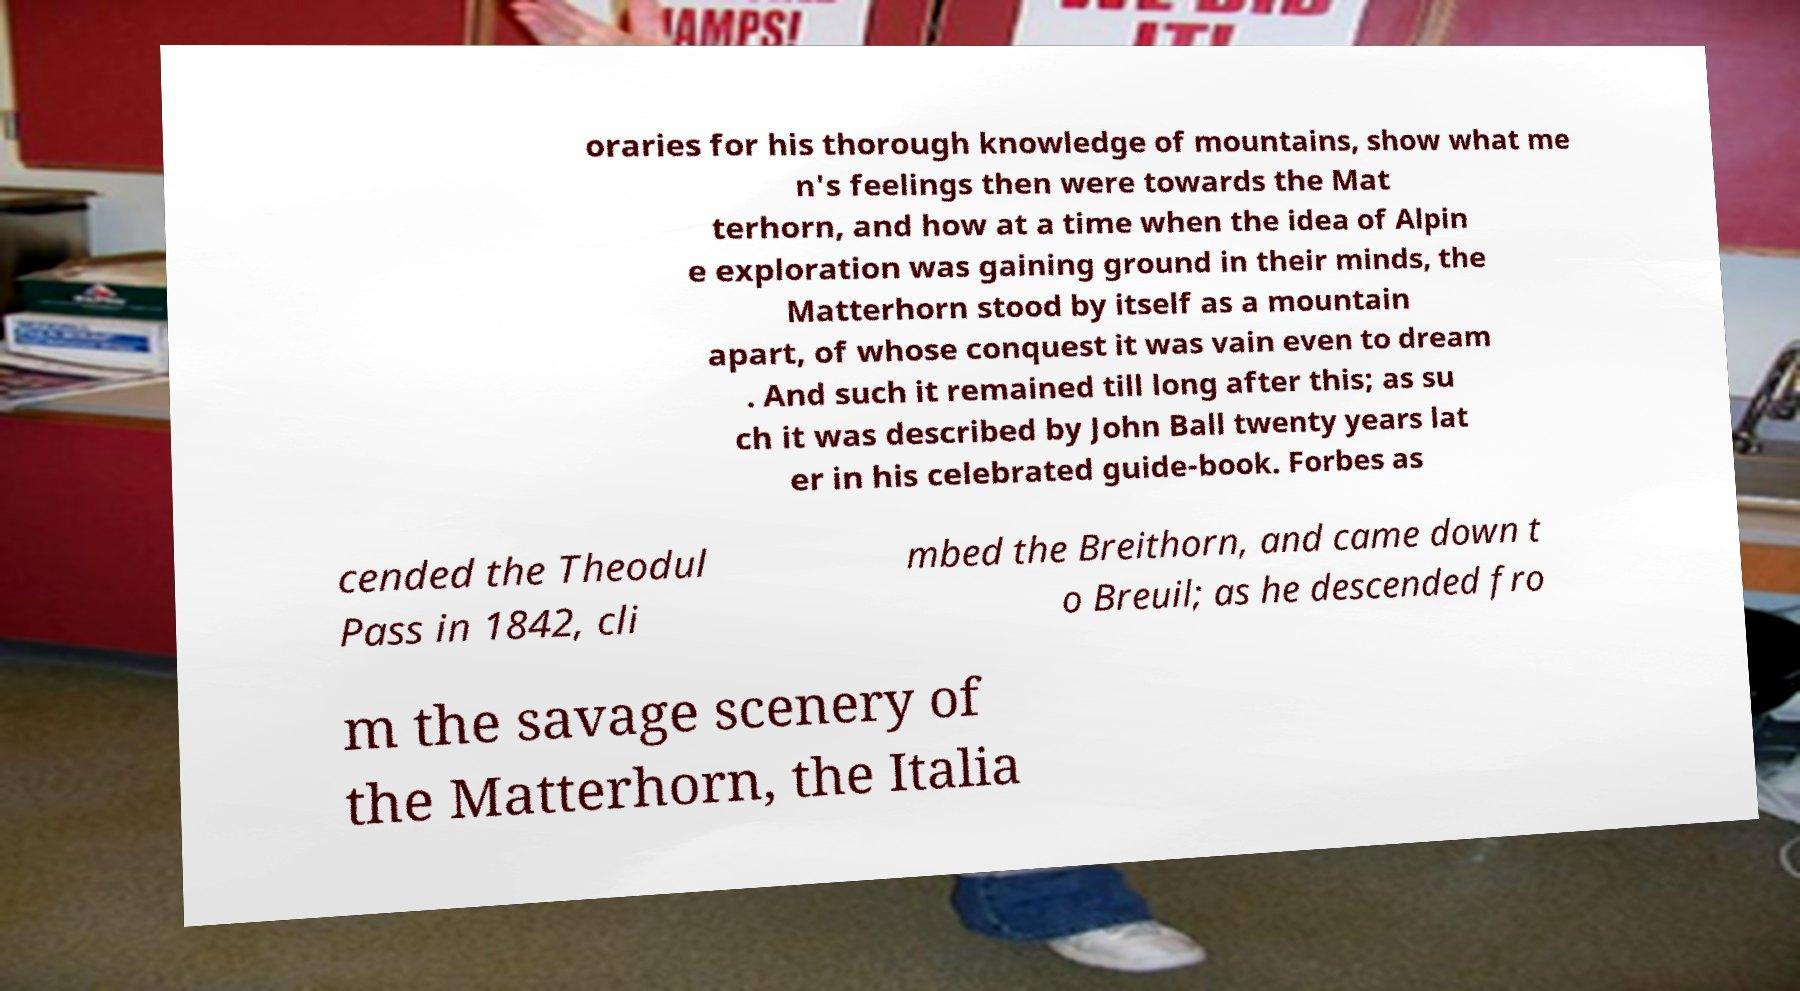Could you extract and type out the text from this image? oraries for his thorough knowledge of mountains, show what me n's feelings then were towards the Mat terhorn, and how at a time when the idea of Alpin e exploration was gaining ground in their minds, the Matterhorn stood by itself as a mountain apart, of whose conquest it was vain even to dream . And such it remained till long after this; as su ch it was described by John Ball twenty years lat er in his celebrated guide-book. Forbes as cended the Theodul Pass in 1842, cli mbed the Breithorn, and came down t o Breuil; as he descended fro m the savage scenery of the Matterhorn, the Italia 